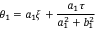<formula> <loc_0><loc_0><loc_500><loc_500>\theta _ { 1 } = a _ { 1 } \xi + \frac { a _ { 1 } \tau } { a _ { 1 } ^ { 2 } + b _ { 1 } ^ { 2 } }</formula> 